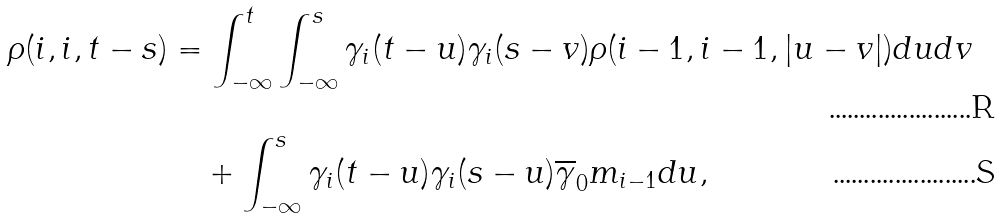Convert formula to latex. <formula><loc_0><loc_0><loc_500><loc_500>\rho ( i , i , t - s ) & = \int _ { - \infty } ^ { t } \int _ { - \infty } ^ { s } \gamma _ { i } ( t - u ) \gamma _ { i } ( s - v ) \rho ( i - 1 , i - 1 , | u - v | ) d u d v \\ & \quad + \int _ { - \infty } ^ { s } \gamma _ { i } ( t - u ) \gamma _ { i } ( s - u ) \overline { \gamma } _ { 0 } m _ { i - 1 } d u ,</formula> 